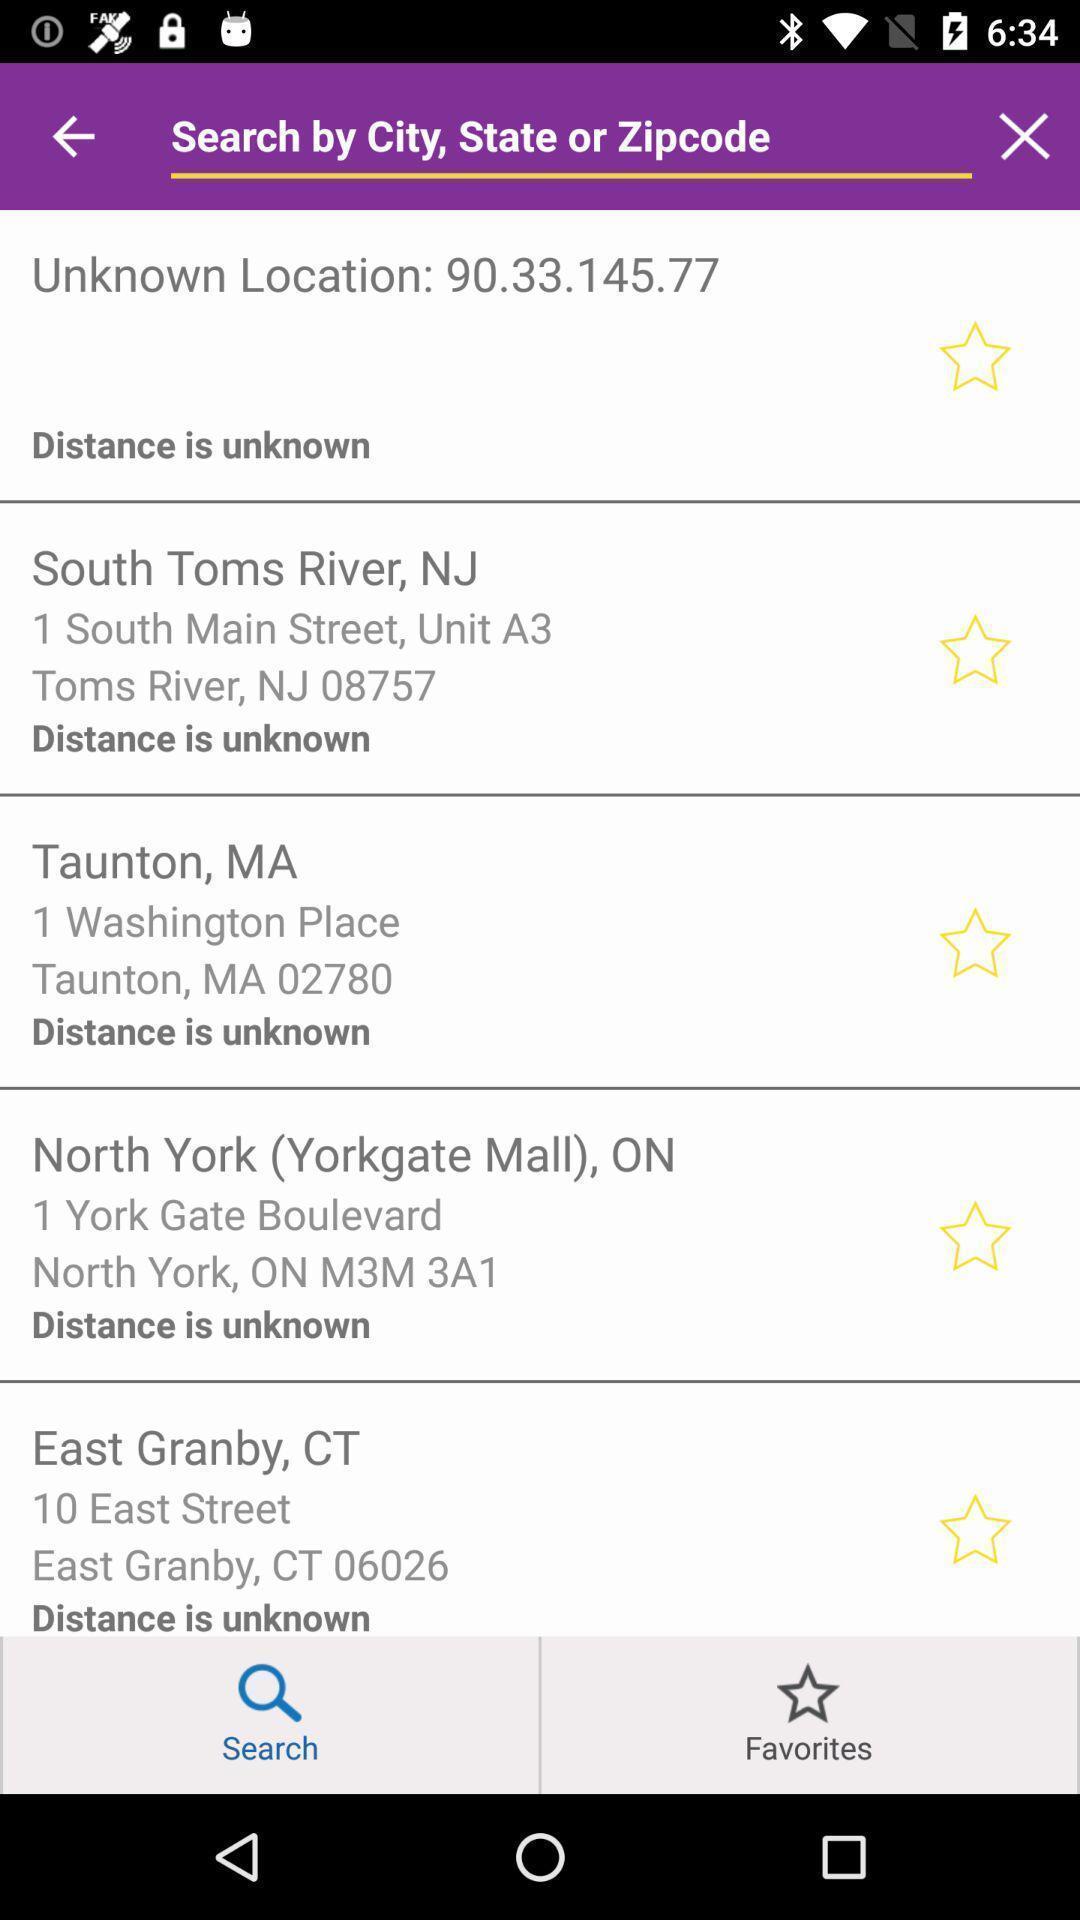Explain the elements present in this screenshot. Search page to find location and distance. 